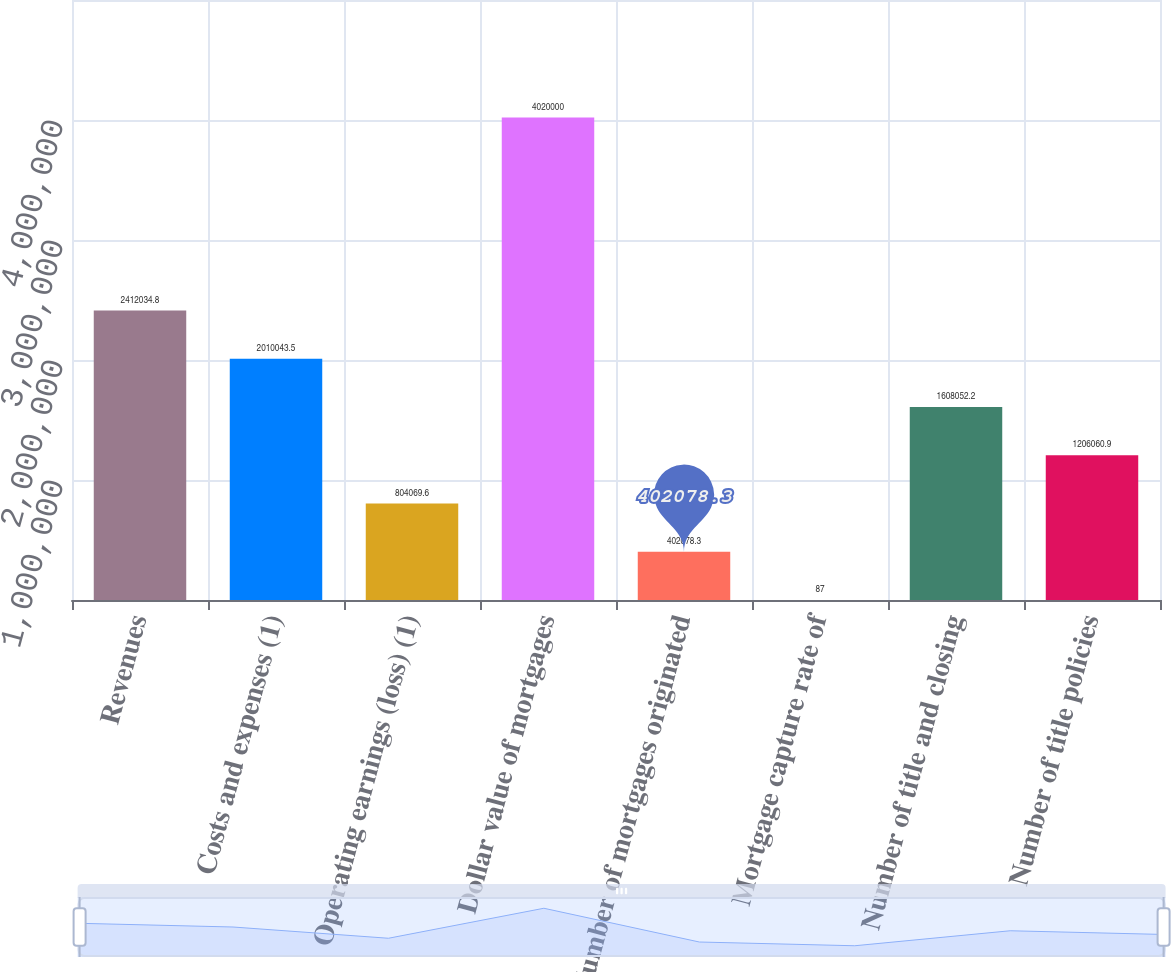Convert chart. <chart><loc_0><loc_0><loc_500><loc_500><bar_chart><fcel>Revenues<fcel>Costs and expenses (1)<fcel>Operating earnings (loss) (1)<fcel>Dollar value of mortgages<fcel>Number of mortgages originated<fcel>Mortgage capture rate of<fcel>Number of title and closing<fcel>Number of title policies<nl><fcel>2.41203e+06<fcel>2.01004e+06<fcel>804070<fcel>4.02e+06<fcel>402078<fcel>87<fcel>1.60805e+06<fcel>1.20606e+06<nl></chart> 